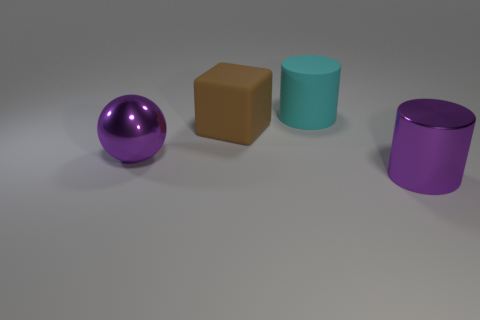Add 3 small metallic cylinders. How many objects exist? 7 Subtract all purple cylinders. How many cylinders are left? 1 Subtract all cubes. How many objects are left? 3 Subtract 1 spheres. How many spheres are left? 0 Subtract all gray blocks. Subtract all cyan balls. How many blocks are left? 1 Subtract all purple cubes. How many green cylinders are left? 0 Subtract all rubber objects. Subtract all large purple balls. How many objects are left? 1 Add 4 big purple cylinders. How many big purple cylinders are left? 5 Add 2 large yellow spheres. How many large yellow spheres exist? 2 Subtract 1 cyan cylinders. How many objects are left? 3 